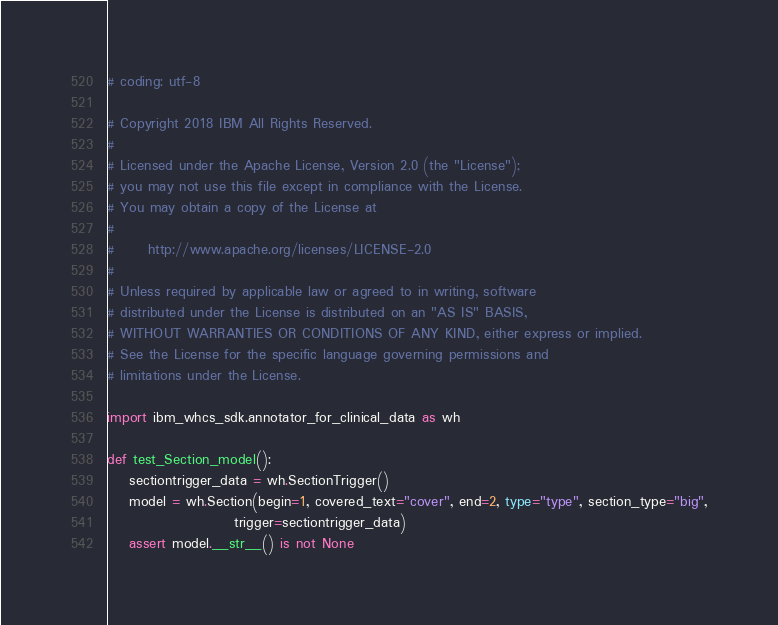Convert code to text. <code><loc_0><loc_0><loc_500><loc_500><_Python_># coding: utf-8

# Copyright 2018 IBM All Rights Reserved.
#
# Licensed under the Apache License, Version 2.0 (the "License");
# you may not use this file except in compliance with the License.
# You may obtain a copy of the License at
#
#      http://www.apache.org/licenses/LICENSE-2.0
#
# Unless required by applicable law or agreed to in writing, software
# distributed under the License is distributed on an "AS IS" BASIS,
# WITHOUT WARRANTIES OR CONDITIONS OF ANY KIND, either express or implied.
# See the License for the specific language governing permissions and
# limitations under the License.

import ibm_whcs_sdk.annotator_for_clinical_data as wh

def test_Section_model():
    sectiontrigger_data = wh.SectionTrigger()
    model = wh.Section(begin=1, covered_text="cover", end=2, type="type", section_type="big",
                       trigger=sectiontrigger_data)
    assert model.__str__() is not None
</code> 